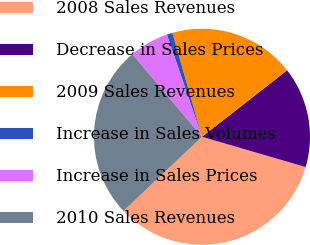Convert chart. <chart><loc_0><loc_0><loc_500><loc_500><pie_chart><fcel>2008 Sales Revenues<fcel>Decrease in Sales Prices<fcel>2009 Sales Revenues<fcel>Increase in Sales Volumes<fcel>Increase in Sales Prices<fcel>2010 Sales Revenues<nl><fcel>33.42%<fcel>15.08%<fcel>18.86%<fcel>0.85%<fcel>5.87%<fcel>25.92%<nl></chart> 